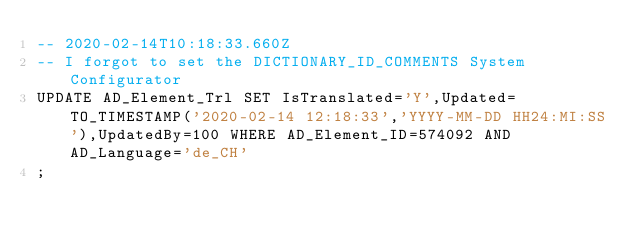<code> <loc_0><loc_0><loc_500><loc_500><_SQL_>-- 2020-02-14T10:18:33.660Z
-- I forgot to set the DICTIONARY_ID_COMMENTS System Configurator
UPDATE AD_Element_Trl SET IsTranslated='Y',Updated=TO_TIMESTAMP('2020-02-14 12:18:33','YYYY-MM-DD HH24:MI:SS'),UpdatedBy=100 WHERE AD_Element_ID=574092 AND AD_Language='de_CH'
;
</code> 